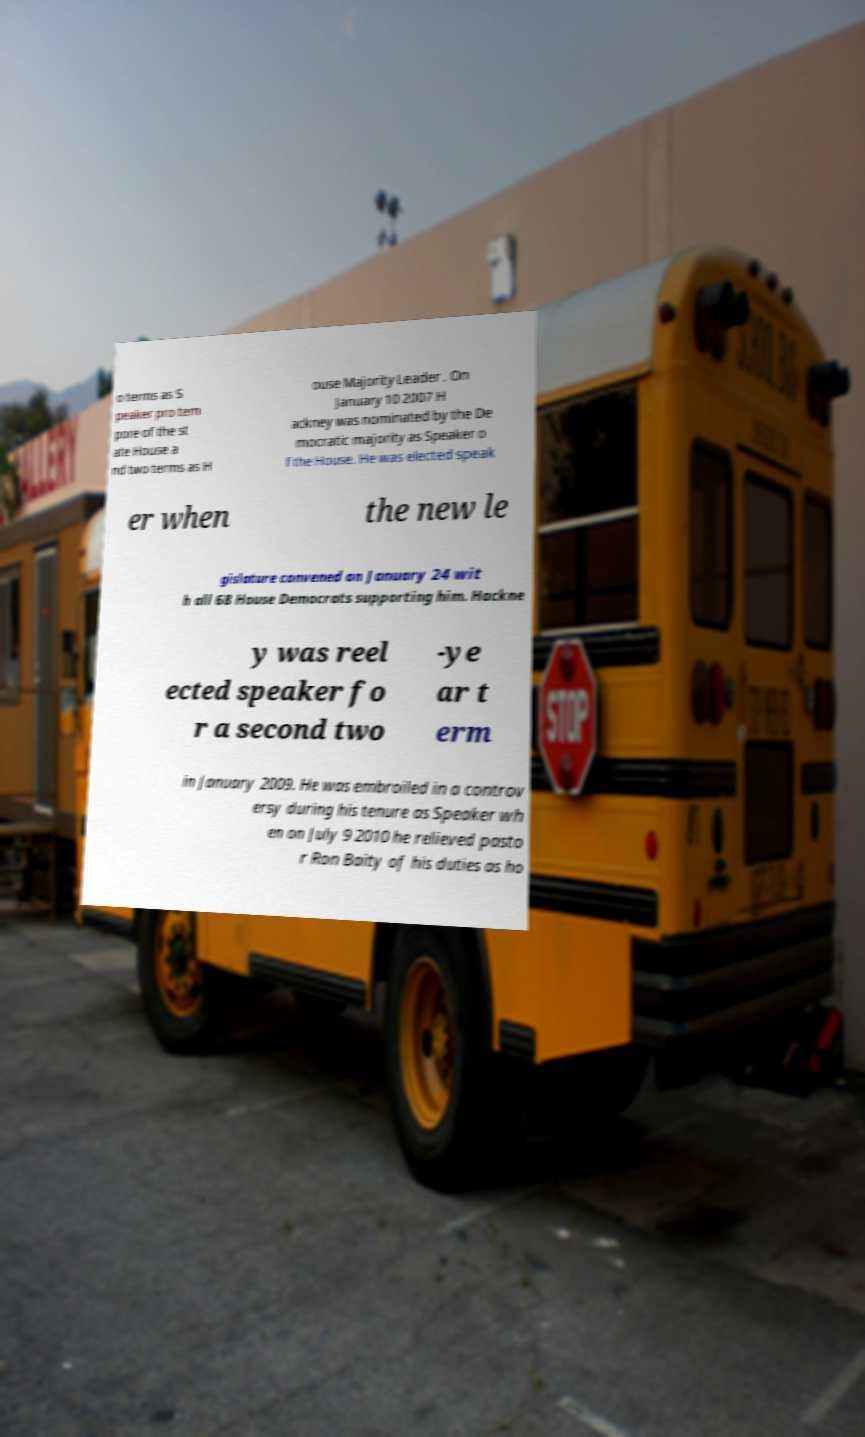What messages or text are displayed in this image? I need them in a readable, typed format. o terms as S peaker pro tem pore of the st ate House a nd two terms as H ouse Majority Leader . On January 10 2007 H ackney was nominated by the De mocratic majority as Speaker o f the House. He was elected speak er when the new le gislature convened on January 24 wit h all 68 House Democrats supporting him. Hackne y was reel ected speaker fo r a second two -ye ar t erm in January 2009. He was embroiled in a controv ersy during his tenure as Speaker wh en on July 9 2010 he relieved pasto r Ron Baity of his duties as ho 